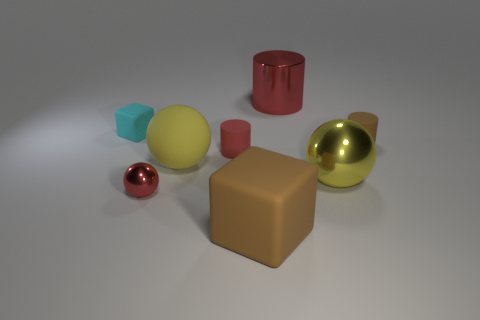Subtract all yellow cubes. How many red cylinders are left? 2 Subtract 1 cylinders. How many cylinders are left? 2 Add 1 big purple metallic cylinders. How many objects exist? 9 Subtract all cubes. How many objects are left? 6 Add 3 big yellow rubber balls. How many big yellow rubber balls are left? 4 Add 4 brown objects. How many brown objects exist? 6 Subtract 0 purple cylinders. How many objects are left? 8 Subtract all small cyan rubber balls. Subtract all large brown objects. How many objects are left? 7 